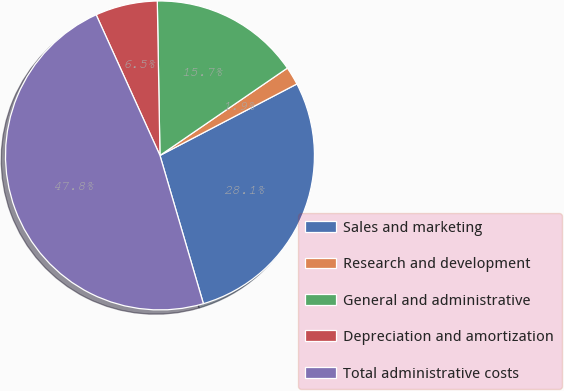<chart> <loc_0><loc_0><loc_500><loc_500><pie_chart><fcel>Sales and marketing<fcel>Research and development<fcel>General and administrative<fcel>Depreciation and amortization<fcel>Total administrative costs<nl><fcel>28.12%<fcel>1.91%<fcel>15.71%<fcel>6.5%<fcel>47.76%<nl></chart> 